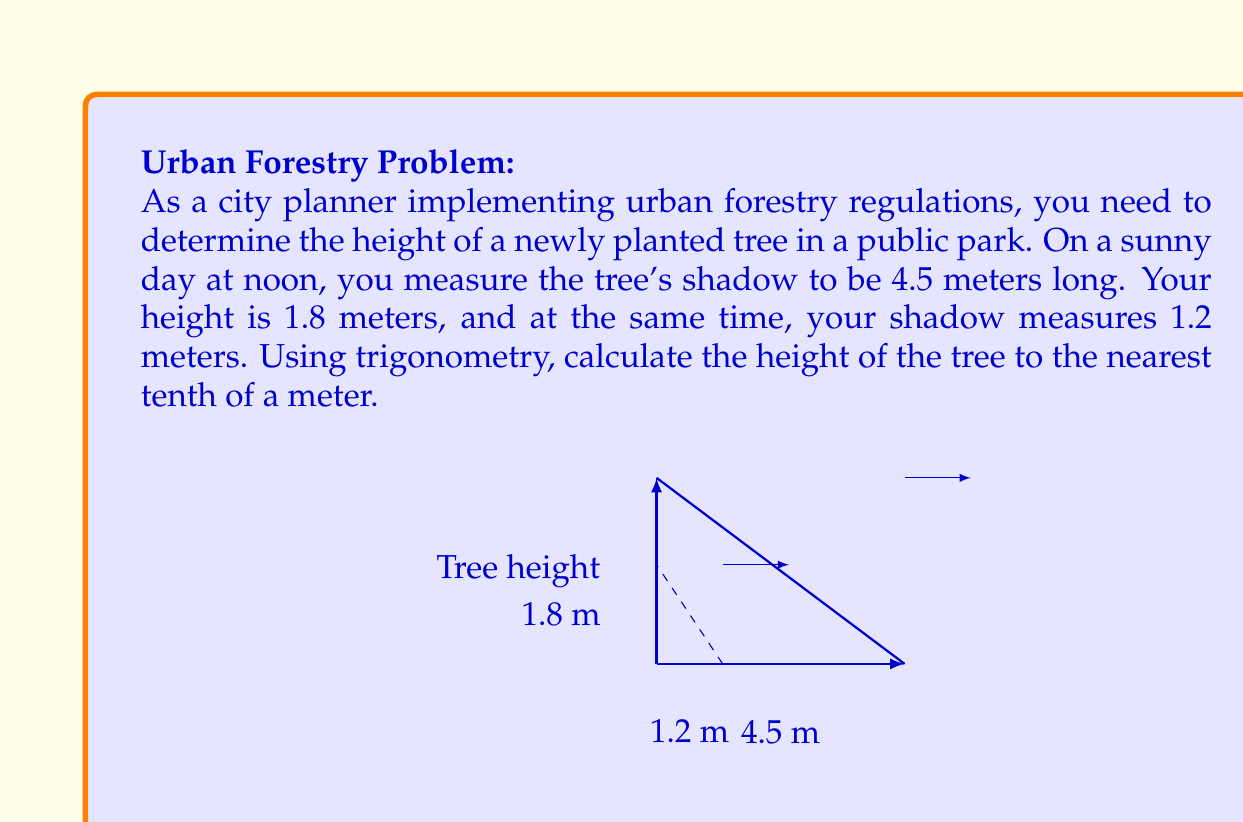Can you answer this question? To solve this problem, we'll use the concept of similar triangles and trigonometry. The triangle formed by the tree and its shadow is similar to the triangle formed by you and your shadow.

Let's define the variables:
- $h$ = height of the tree (unknown)
- $s_t$ = length of the tree's shadow = 4.5 m
- $h_p$ = your height = 1.8 m
- $s_p$ = length of your shadow = 1.2 m

The ratio of the tree's height to its shadow length should be equal to the ratio of your height to your shadow length:

$$\frac{h}{s_t} = \frac{h_p}{s_p}$$

We can cross-multiply to solve for $h$:

$$h \cdot s_p = h_p \cdot s_t$$

$$h = \frac{h_p \cdot s_t}{s_p}$$

Now, let's substitute the known values:

$$h = \frac{1.8 \text{ m} \cdot 4.5 \text{ m}}{1.2 \text{ m}}$$

$$h = \frac{8.1 \text{ m}^2}{1.2 \text{ m}}$$

$$h = 6.75 \text{ m}$$

Rounding to the nearest tenth of a meter:

$$h \approx 6.8 \text{ m}$$

Therefore, the height of the tree is approximately 6.8 meters.
Answer: $6.8 \text{ meters}$ 